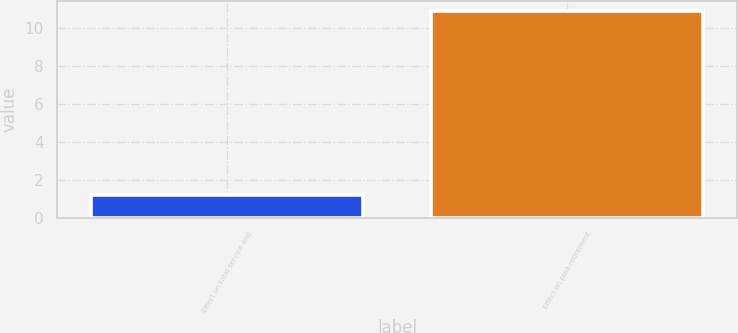Convert chart to OTSL. <chart><loc_0><loc_0><loc_500><loc_500><bar_chart><fcel>Effect on total service and<fcel>Effect on post-retirement<nl><fcel>1.2<fcel>10.9<nl></chart> 